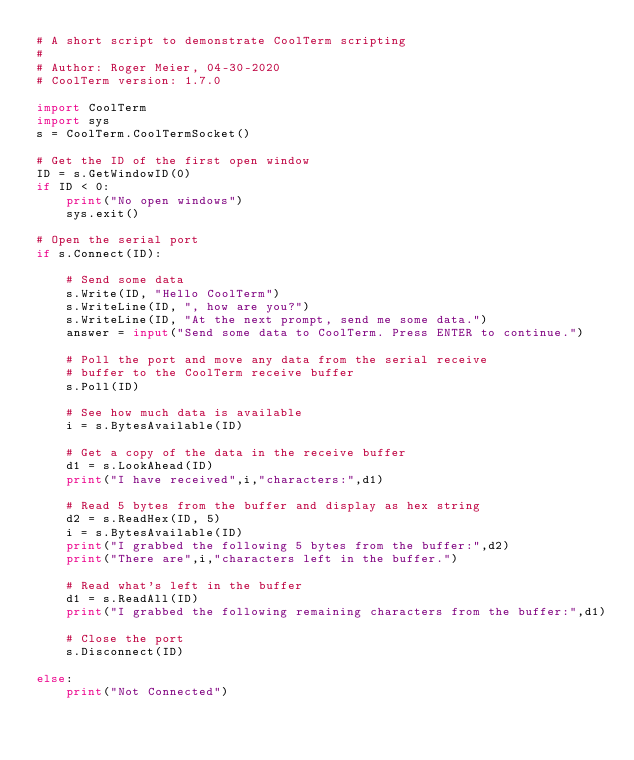Convert code to text. <code><loc_0><loc_0><loc_500><loc_500><_Python_># A short script to demonstrate CoolTerm scripting
#
# Author: Roger Meier, 04-30-2020
# CoolTerm version: 1.7.0

import CoolTerm
import sys
s = CoolTerm.CoolTermSocket()

# Get the ID of the first open window
ID = s.GetWindowID(0)
if ID < 0:
    print("No open windows")
    sys.exit()

# Open the serial port
if s.Connect(ID):
    
    # Send some data
    s.Write(ID, "Hello CoolTerm")
    s.WriteLine(ID, ", how are you?")
    s.WriteLine(ID, "At the next prompt, send me some data.")
    answer = input("Send some data to CoolTerm. Press ENTER to continue.")

    # Poll the port and move any data from the serial receive
    # buffer to the CoolTerm receive buffer
    s.Poll(ID)

    # See how much data is available
    i = s.BytesAvailable(ID)

    # Get a copy of the data in the receive buffer
    d1 = s.LookAhead(ID)
    print("I have received",i,"characters:",d1)

    # Read 5 bytes from the buffer and display as hex string
    d2 = s.ReadHex(ID, 5)
    i = s.BytesAvailable(ID)
    print("I grabbed the following 5 bytes from the buffer:",d2)
    print("There are",i,"characters left in the buffer.")

    # Read what's left in the buffer
    d1 = s.ReadAll(ID)
    print("I grabbed the following remaining characters from the buffer:",d1)

    # Close the port
    s.Disconnect(ID)

else:
    print("Not Connected")
</code> 